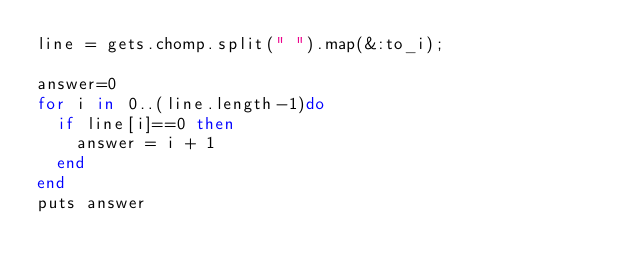<code> <loc_0><loc_0><loc_500><loc_500><_Ruby_>line = gets.chomp.split(" ").map(&:to_i);

answer=0
for i in 0..(line.length-1)do
	if line[i]==0 then
		answer = i + 1
	end
end
puts answer

</code> 